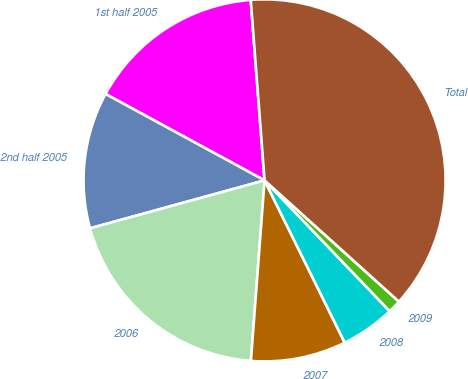Convert chart. <chart><loc_0><loc_0><loc_500><loc_500><pie_chart><fcel>1st half 2005<fcel>2nd half 2005<fcel>2006<fcel>2007<fcel>2008<fcel>2009<fcel>Total<nl><fcel>15.86%<fcel>12.19%<fcel>19.53%<fcel>8.51%<fcel>4.84%<fcel>1.17%<fcel>37.9%<nl></chart> 